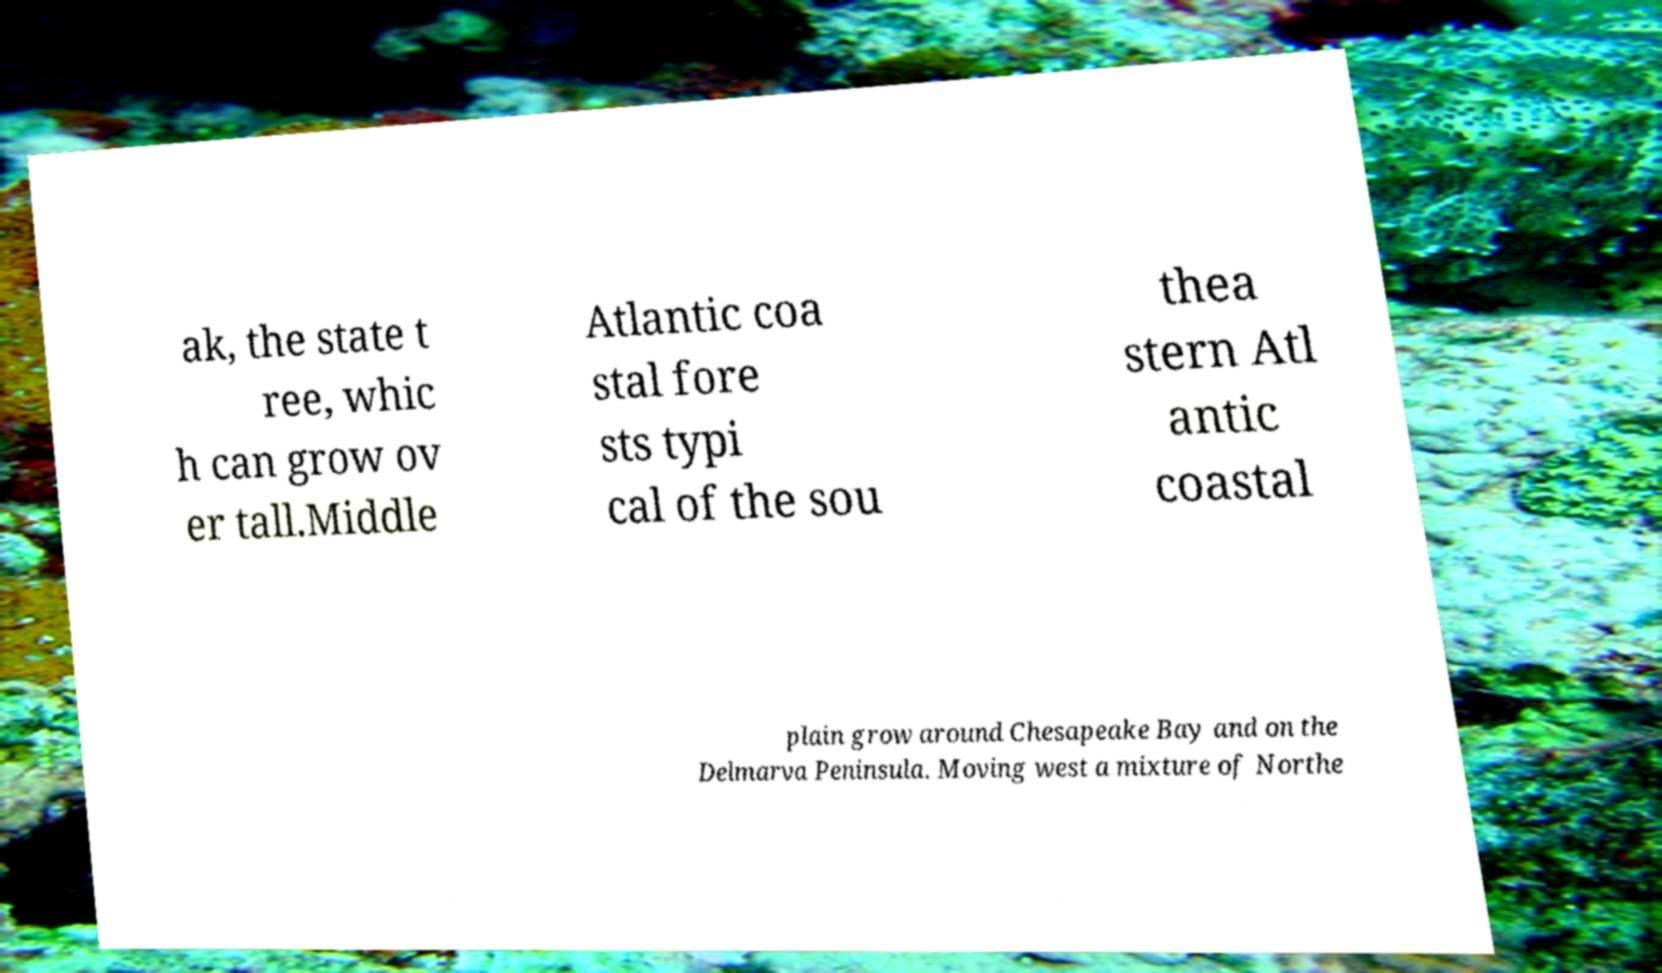Could you extract and type out the text from this image? ak, the state t ree, whic h can grow ov er tall.Middle Atlantic coa stal fore sts typi cal of the sou thea stern Atl antic coastal plain grow around Chesapeake Bay and on the Delmarva Peninsula. Moving west a mixture of Northe 